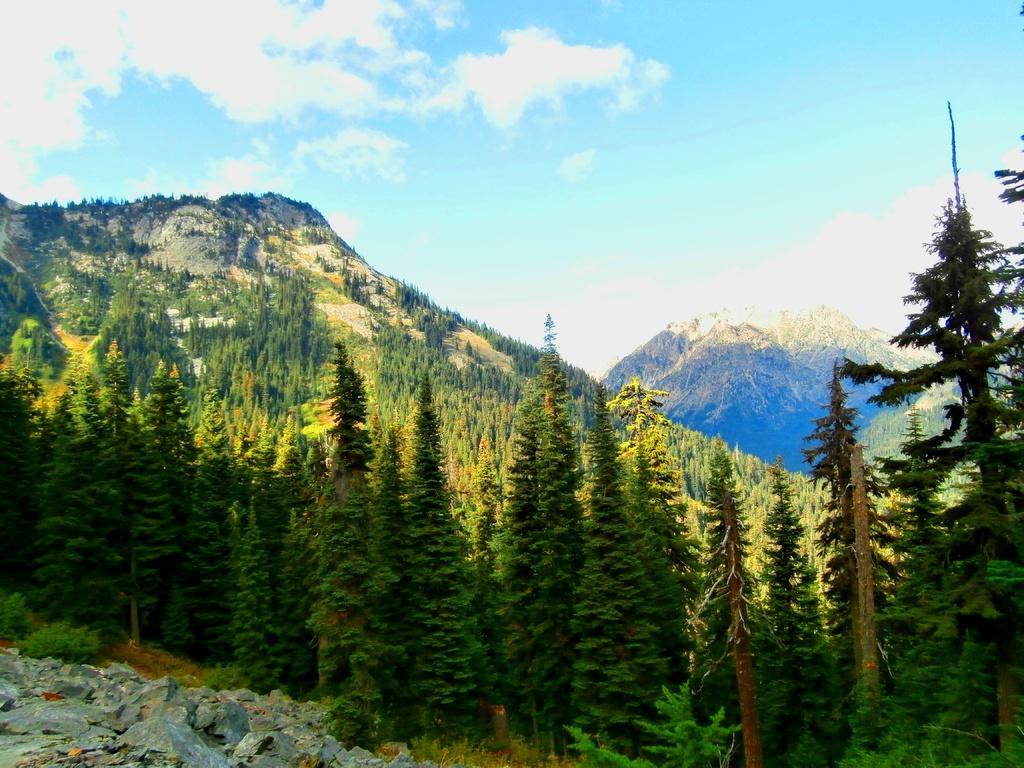Please provide a concise description of this image. In this image I can see number of trees and a clear blue sky. I can also see mountains. 